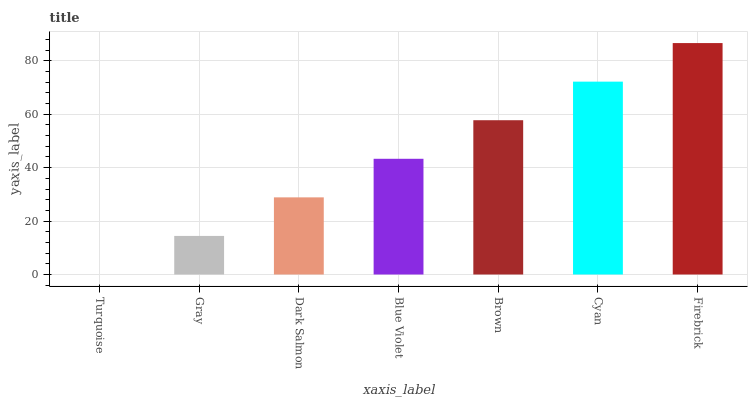Is Turquoise the minimum?
Answer yes or no. Yes. Is Firebrick the maximum?
Answer yes or no. Yes. Is Gray the minimum?
Answer yes or no. No. Is Gray the maximum?
Answer yes or no. No. Is Gray greater than Turquoise?
Answer yes or no. Yes. Is Turquoise less than Gray?
Answer yes or no. Yes. Is Turquoise greater than Gray?
Answer yes or no. No. Is Gray less than Turquoise?
Answer yes or no. No. Is Blue Violet the high median?
Answer yes or no. Yes. Is Blue Violet the low median?
Answer yes or no. Yes. Is Turquoise the high median?
Answer yes or no. No. Is Firebrick the low median?
Answer yes or no. No. 